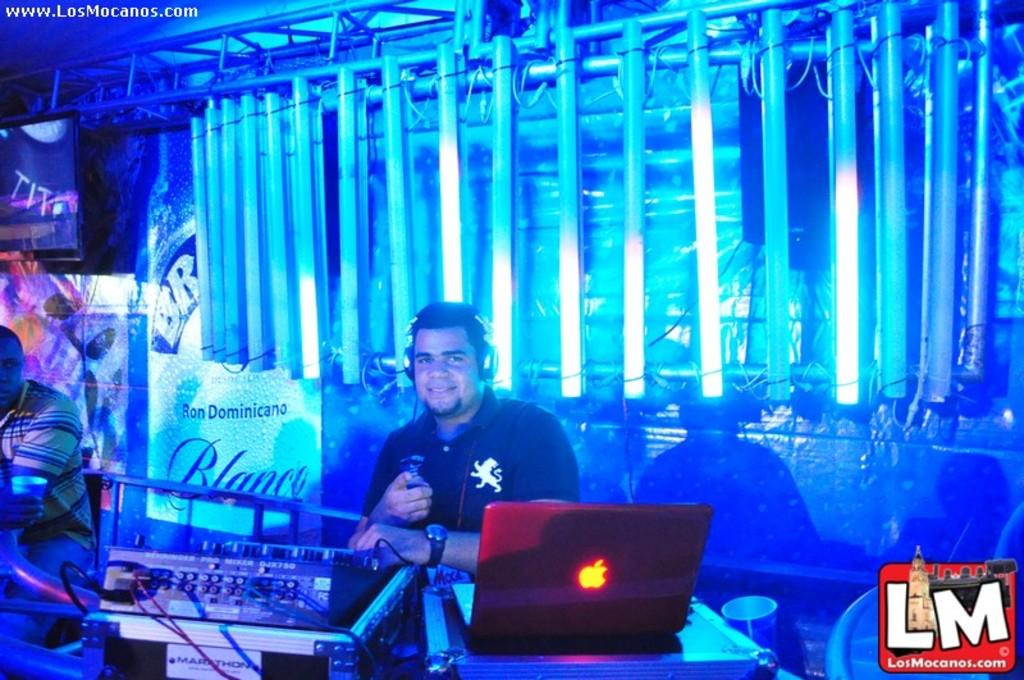Provide a one-sentence caption for the provided image. the label of LM that is at the club. 